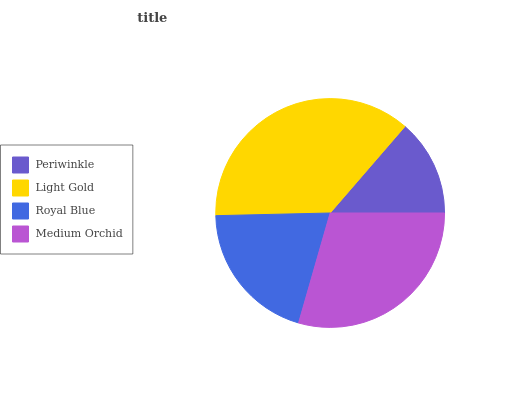Is Periwinkle the minimum?
Answer yes or no. Yes. Is Light Gold the maximum?
Answer yes or no. Yes. Is Royal Blue the minimum?
Answer yes or no. No. Is Royal Blue the maximum?
Answer yes or no. No. Is Light Gold greater than Royal Blue?
Answer yes or no. Yes. Is Royal Blue less than Light Gold?
Answer yes or no. Yes. Is Royal Blue greater than Light Gold?
Answer yes or no. No. Is Light Gold less than Royal Blue?
Answer yes or no. No. Is Medium Orchid the high median?
Answer yes or no. Yes. Is Royal Blue the low median?
Answer yes or no. Yes. Is Periwinkle the high median?
Answer yes or no. No. Is Periwinkle the low median?
Answer yes or no. No. 